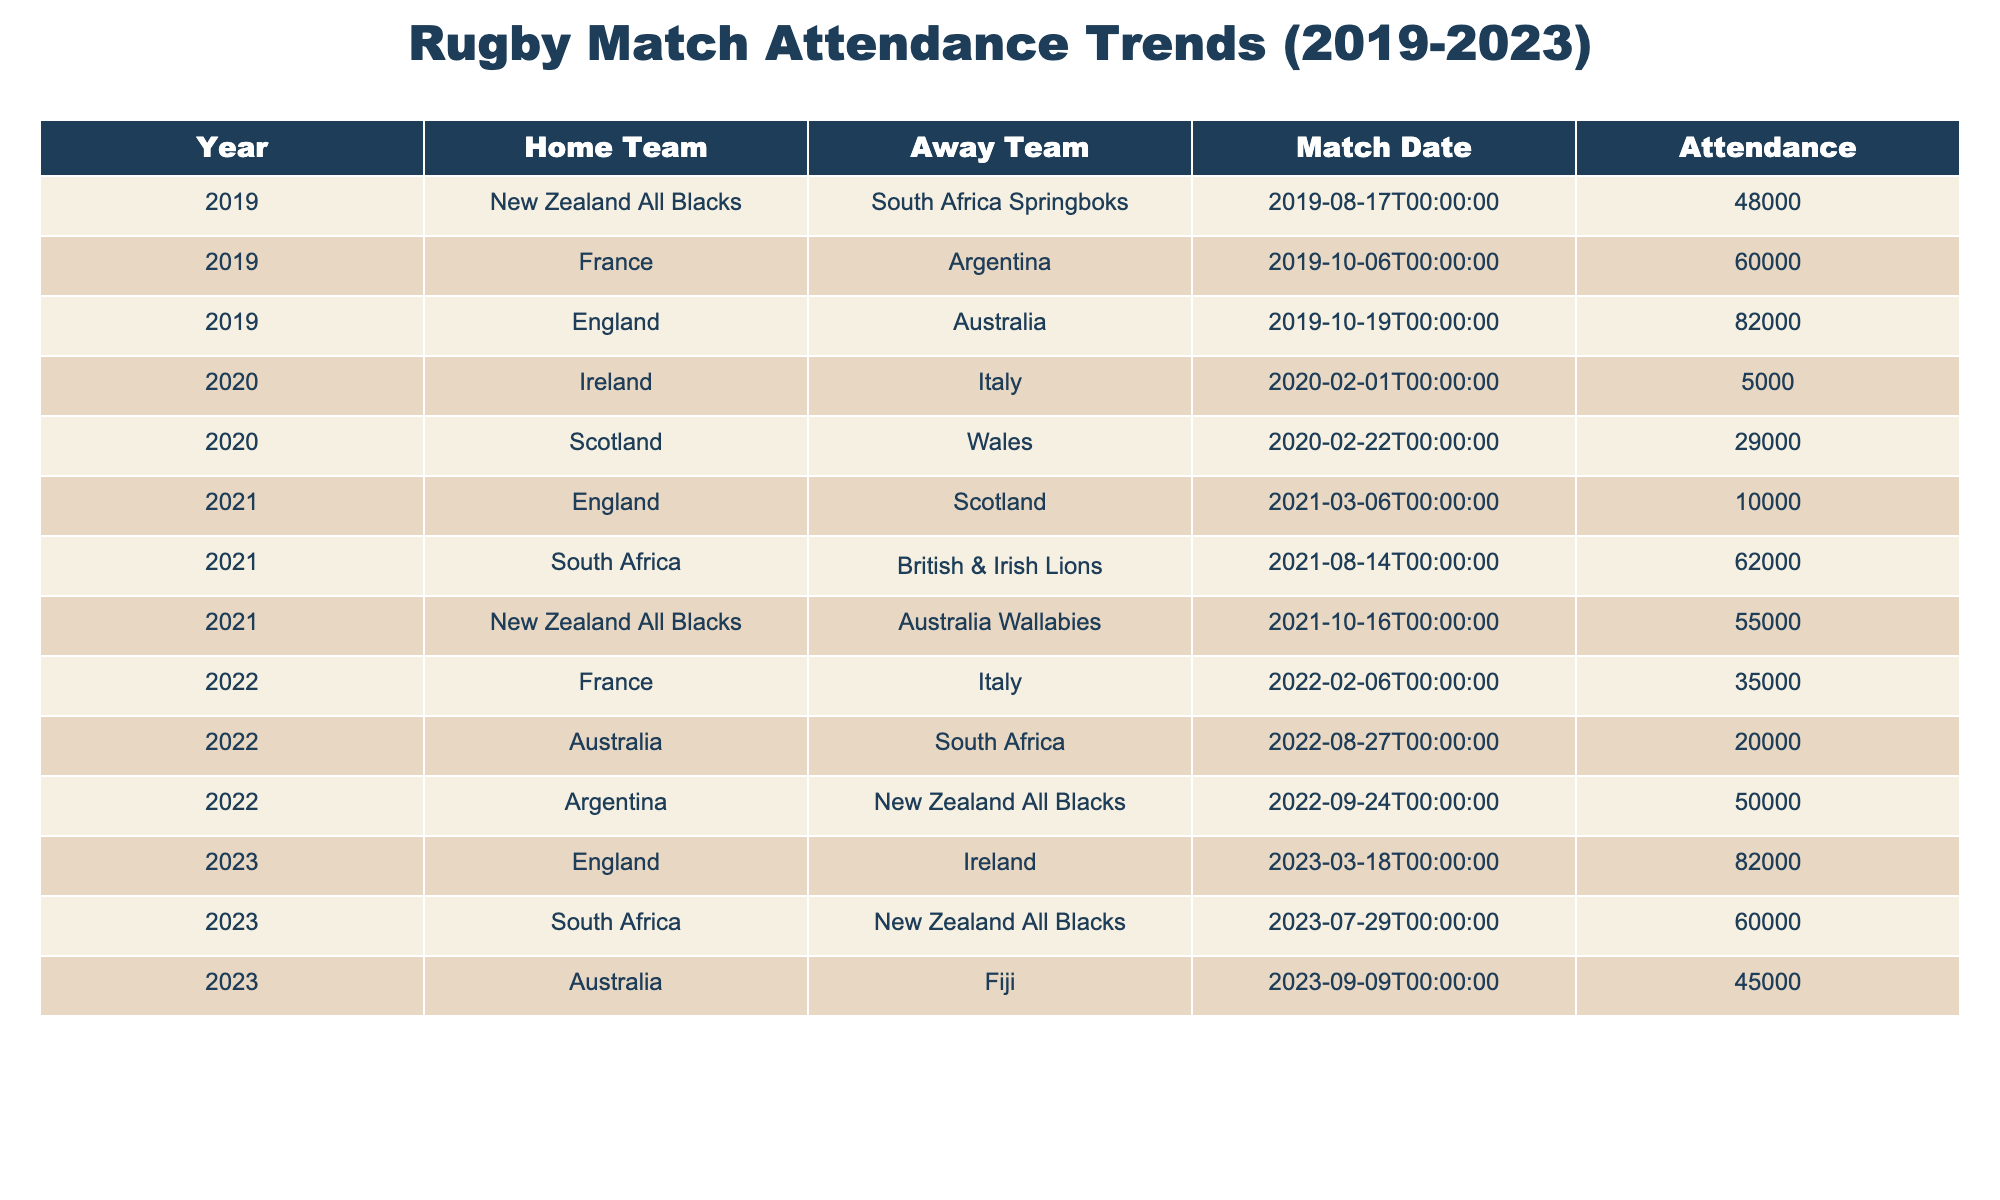What was the highest attendance recorded in 2023? Looking at the attendance figures for 2023, the matches are England vs. Ireland with 82000, South Africa vs. New Zealand All Blacks with 60000, and Australia vs. Fiji with 45000. Therefore, the highest attendance among these is 82000 for the England vs. Ireland match.
Answer: 82000 Which year had the lowest attendance and what was that number? Scanning through the years, the lowest attendance is in 2020, with the Ireland vs. Italy match recording only 5000 attendees.
Answer: 5000 What was the average attendance from 2019 to 2023? To find the average, we first sum all attendance figures: 48000 + 82000 + 60000 + 5000 + 29000 + 55000 + 10000 + 62000 + 35000 + 50000 + 20000 + 82000 + 60000 + 45000 =  424000. There are 14 matches in total, so the average attendance is 424000 / 14 = 30285.71. Rounding gives us an average of 30286 attendees.
Answer: 30286 Did France play against Argentina in 2020? From the table, the matchups show that France faced Argentina in 2019, but no match is listed between France and Argentina in 2020. Therefore, the answer is no.
Answer: No Which home team had the highest attendance over the listed years? The matches involving home teams show England vs. Australia in 2019 with 82000 and England vs. Ireland in 2023 with 82000. Both have the highest attendance, resulting in England having the highest attendance overall among the home teams.
Answer: England 